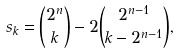<formula> <loc_0><loc_0><loc_500><loc_500>s _ { k } = \binom { 2 ^ { n } } { k } - 2 \binom { 2 ^ { n - 1 } } { k - 2 ^ { n - 1 } } ,</formula> 